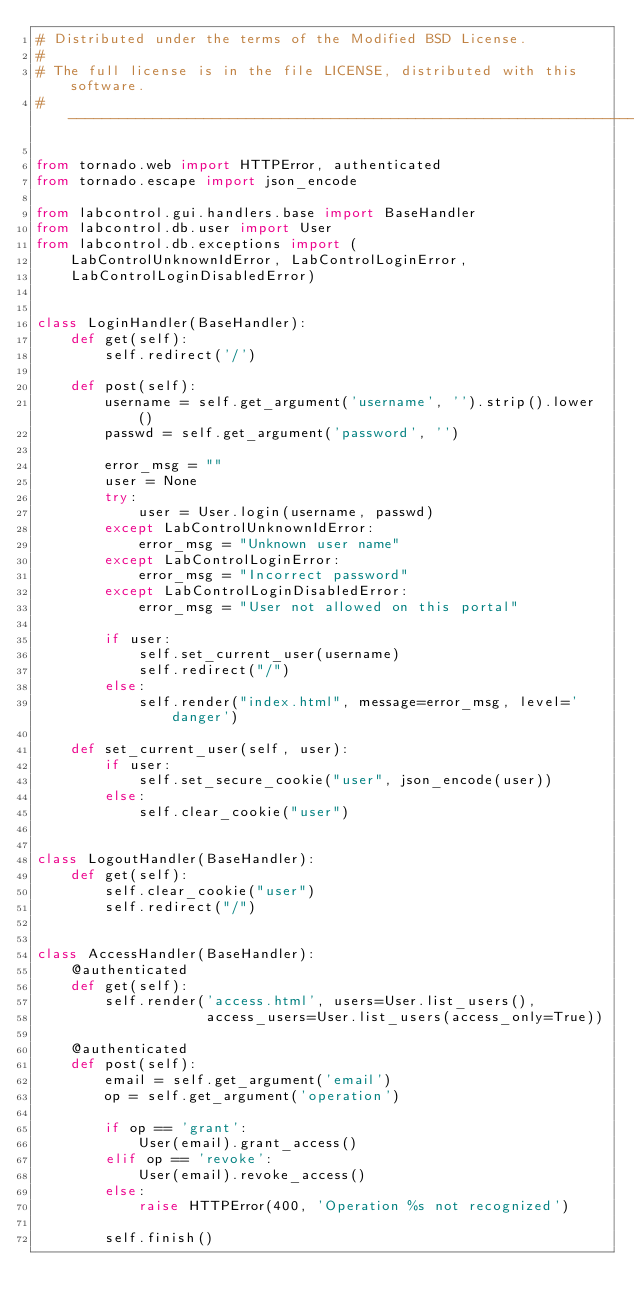Convert code to text. <code><loc_0><loc_0><loc_500><loc_500><_Python_># Distributed under the terms of the Modified BSD License.
#
# The full license is in the file LICENSE, distributed with this software.
# ----------------------------------------------------------------------------

from tornado.web import HTTPError, authenticated
from tornado.escape import json_encode

from labcontrol.gui.handlers.base import BaseHandler
from labcontrol.db.user import User
from labcontrol.db.exceptions import (
    LabControlUnknownIdError, LabControlLoginError,
    LabControlLoginDisabledError)


class LoginHandler(BaseHandler):
    def get(self):
        self.redirect('/')

    def post(self):
        username = self.get_argument('username', '').strip().lower()
        passwd = self.get_argument('password', '')

        error_msg = ""
        user = None
        try:
            user = User.login(username, passwd)
        except LabControlUnknownIdError:
            error_msg = "Unknown user name"
        except LabControlLoginError:
            error_msg = "Incorrect password"
        except LabControlLoginDisabledError:
            error_msg = "User not allowed on this portal"

        if user:
            self.set_current_user(username)
            self.redirect("/")
        else:
            self.render("index.html", message=error_msg, level='danger')

    def set_current_user(self, user):
        if user:
            self.set_secure_cookie("user", json_encode(user))
        else:
            self.clear_cookie("user")


class LogoutHandler(BaseHandler):
    def get(self):
        self.clear_cookie("user")
        self.redirect("/")


class AccessHandler(BaseHandler):
    @authenticated
    def get(self):
        self.render('access.html', users=User.list_users(),
                    access_users=User.list_users(access_only=True))

    @authenticated
    def post(self):
        email = self.get_argument('email')
        op = self.get_argument('operation')

        if op == 'grant':
            User(email).grant_access()
        elif op == 'revoke':
            User(email).revoke_access()
        else:
            raise HTTPError(400, 'Operation %s not recognized')

        self.finish()
</code> 